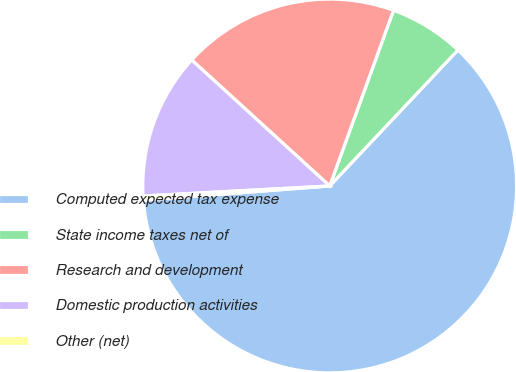Convert chart. <chart><loc_0><loc_0><loc_500><loc_500><pie_chart><fcel>Computed expected tax expense<fcel>State income taxes net of<fcel>Research and development<fcel>Domestic production activities<fcel>Other (net)<nl><fcel>61.75%<fcel>6.49%<fcel>18.77%<fcel>12.63%<fcel>0.35%<nl></chart> 